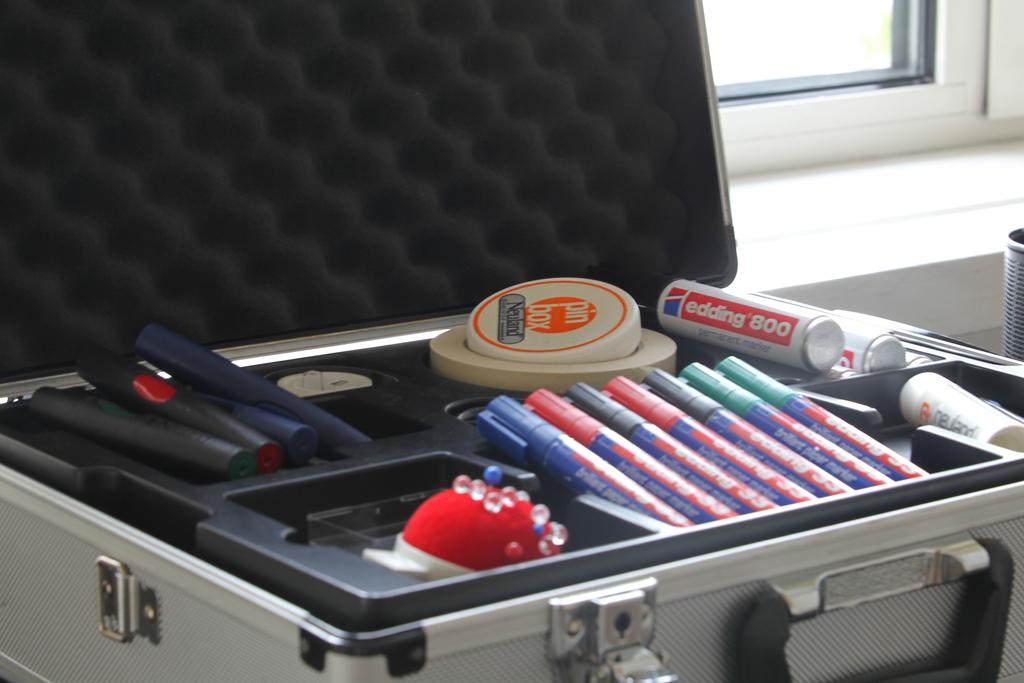What object can be seen in the image that is commonly used for traveling? There is a suitcase in the image that can be used for traveling in the image. What is inside the suitcase? The suitcase contains pens and other unspecified items. What can be seen in the background of the image? There is a window visible in the background of the image. What type of produce can be seen growing in the suitcase in the image? There is no produce growing in the suitcase in the image; it contains pens and other unspecified items. What color is the marble on the window sill in the image? There is no marble visible in the image; only a window is mentioned in the background. 